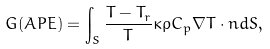Convert formula to latex. <formula><loc_0><loc_0><loc_500><loc_500>G ( A P E ) = \int _ { S } \frac { T - T _ { r } } { T } \kappa \rho C _ { p } \nabla T \cdot { n } d S ,</formula> 